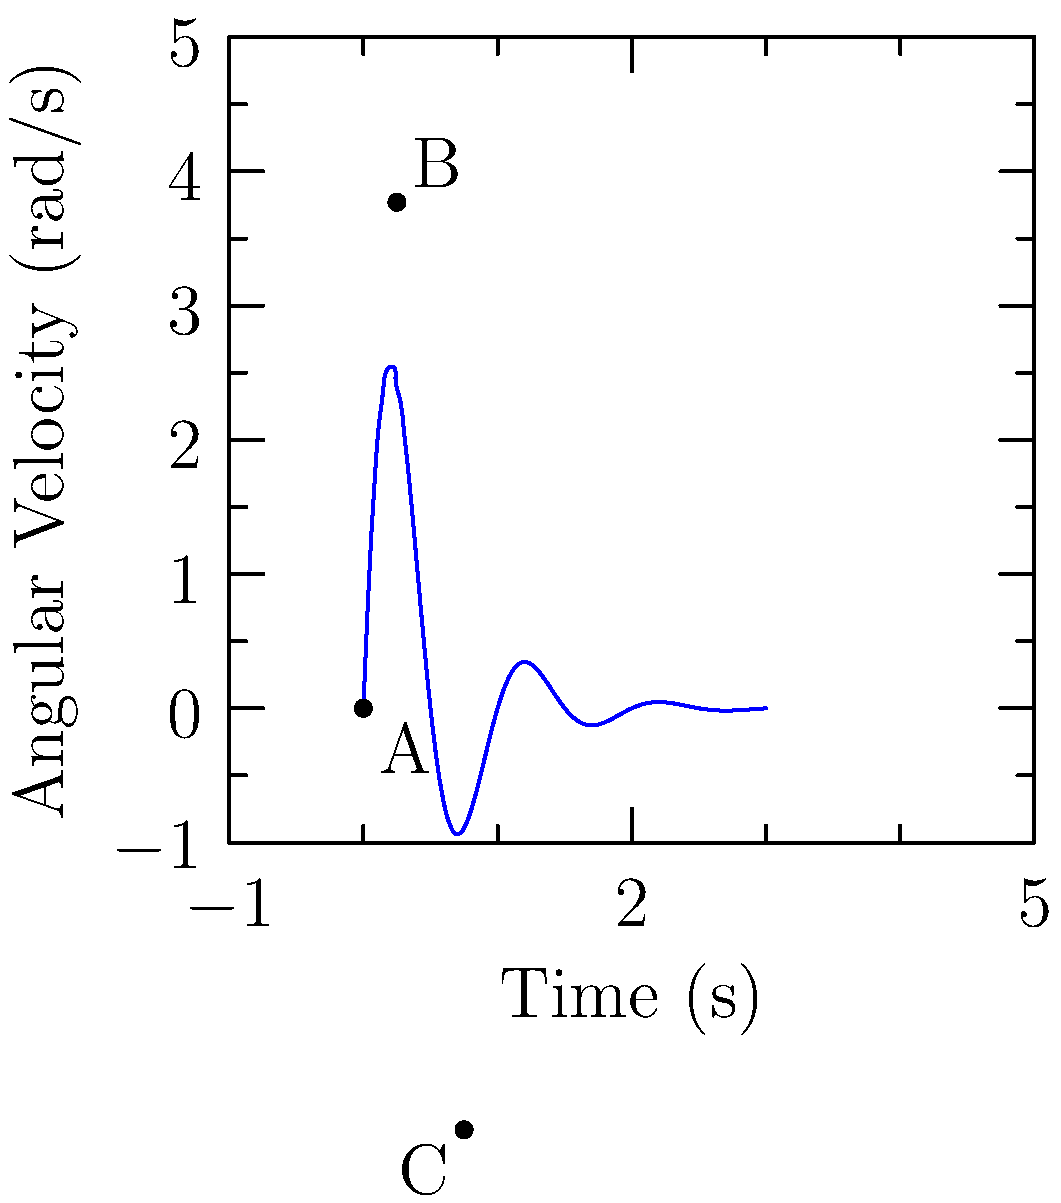Given the graph of angular velocity vs. time for a baseball pitcher's throwing arm during a pitch, calculate the total angular displacement of the arm between points A and C. Assume the motion can be modeled as a damped harmonic oscillator. How might this analysis be relevant in the context of blockchain technology and sports analytics? To solve this problem, we'll follow these steps:

1) The angular velocity $\omega(t)$ is given by the equation:
   $$\omega(t) = 4e^{-t/0.5}\sin(2\pi t)$$

2) To find the angular displacement, we need to integrate the angular velocity:
   $$\theta = \int_{t_A}^{t_C} \omega(t) dt$$

3) The limits of integration are from $t_A = 0$ to $t_C = 0.75$ seconds.

4) Integrating:
   $$\theta = \int_{0}^{0.75} 4e^{-t/0.5}\sin(2\pi t) dt$$

5) This integral doesn't have a simple analytical solution, so we'll use numerical integration (e.g., Simpson's rule or a computational tool).

6) Using a numerical integration tool, we get:
   $$\theta \approx 0.637 \text{ radians}$$

7) Converting to degrees:
   $$\theta \approx 0.637 \times \frac{180}{\pi} \approx 36.5°$$

Relevance to blockchain and sports analytics:
This type of biomechanical analysis generates large amounts of data that need to be securely stored, shared, and analyzed. Blockchain technology can provide a decentralized, tamper-proof system for storing this data, ensuring its integrity and allowing for secure sharing among teams, coaches, and analysts. Smart contracts could be used to automatically trigger performance-based contract clauses or to manage the rights to player performance data. Additionally, blockchain-based platforms could facilitate the creation of new sports analytics markets, where insights derived from this data could be securely traded or monetized.
Answer: 36.5° (0.637 radians) 